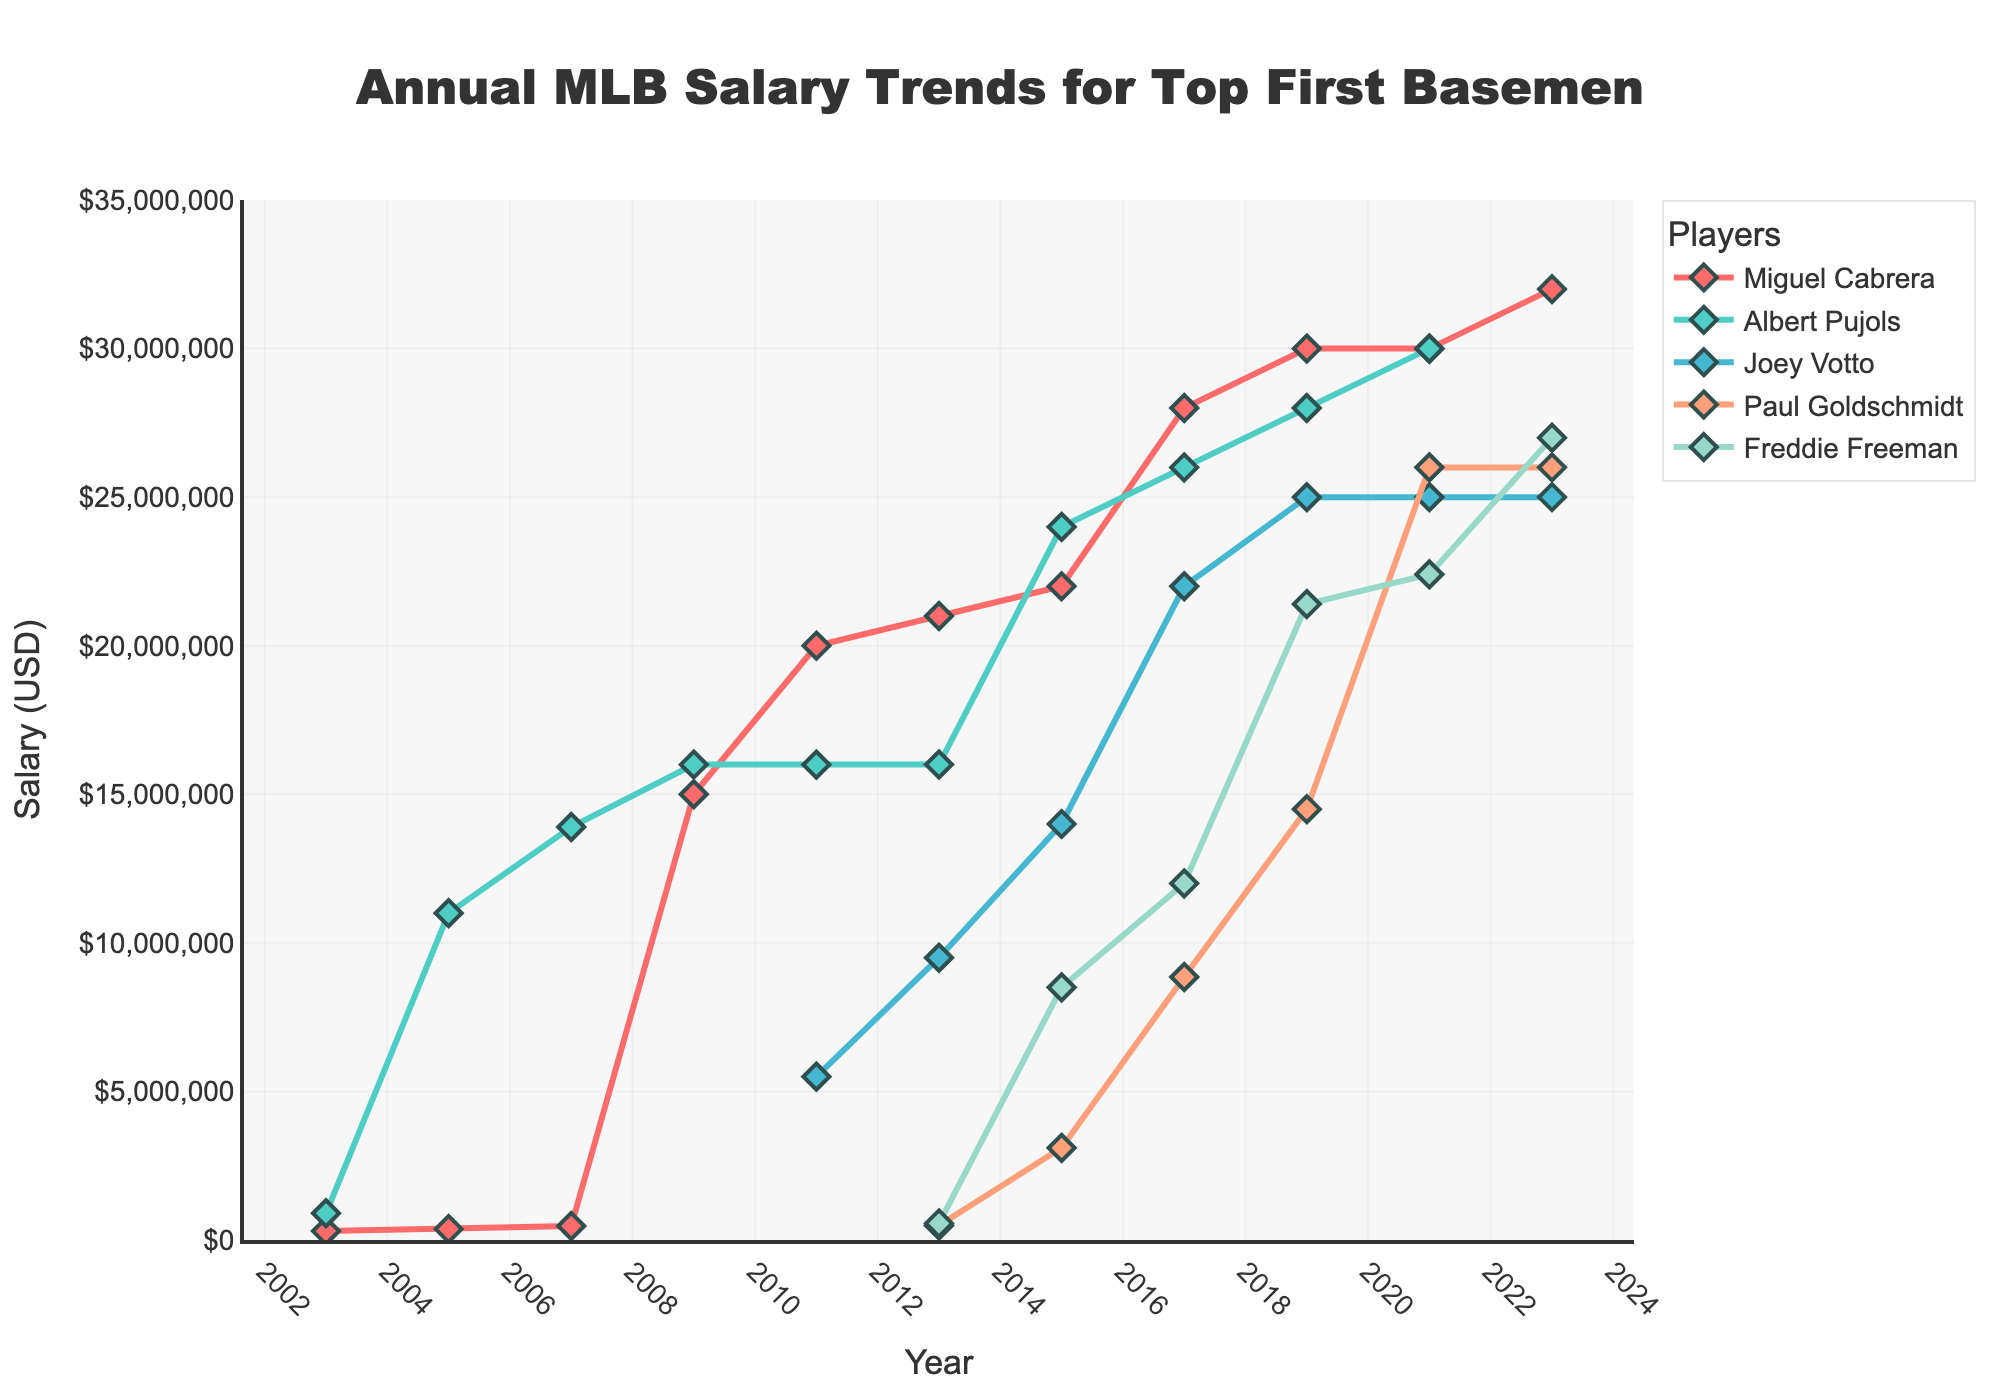What was the highest salary for Miguel Cabrera and in which year did it occur? Look at the trend line for Miguel Cabrera to find the peak salary. The highest salary is 32 million USD, which occurs in 2023.
Answer: 32 million USD, 2023 Who had the highest salary among all players in 2009? In 2009, Miguel Cabrera and Albert Pujols both have salaries. Compare their salary values, and Miguel Cabrera's salary of 15 million USD is lower than Pujols' 16 million USD, so Pujols is the highest paid.
Answer: Albert Pujols In what year did Freddie Freeman's salary first exceed Miguel Cabrera’s salary in the same year? Compare the salary lines for Miguel Cabrera and Freddie Freeman year by year. Freddie Freeman's salary first exceeds Miguel Cabrera's in 2023, with respective salaries of 27 million USD and 32 million USD.
Answer: Never in the given data Among the top first basemen, whose salary showed the most considerable increase between 2017 and 2019? Calculate the salary differences for each player between 2017 and 2019. Miguel Cabrera increased from 28 million USD to 30 million USD (+2 million). Albert Pujols increased from 26 million USD to 28 million USD (+2 million). Joey Votto increased from 22 million USD to 25 million USD (+3 million). Paul Goldschmidt increased from 8.85 million USD to 14.5 million USD (+5.65 million). Freddie Freeman increased from 12 million USD to 21.4 million USD (+9.4 million). Hence, Freddie Freeman had the most considerable increase of 9.4 million USD.
Answer: Freddie Freeman By how much did Joey Votto's salary grow from 2011 to 2019? Subtract Joey Votto's salary in 2011 (5.5 million USD) from his salary in 2019 (25 million USD): 25 million - 5.5 million = 19.5 million USD.
Answer: 19.5 million USD Which player's salary remained constant from 2021 to 2023? Examine the salary lines for all players between 2021 and 2023. Joey Votto's salary remains constant at 25 million USD while other players show changes.
Answer: Joey Votto In 2019, how much more did Miguel Cabrera make compared to Paul Goldschmidt? Subtract Paul Goldschmidt's salary in 2019 (14.5 million USD) from Miguel Cabrera's salary in 2019 (30 million USD): 30 million - 14.5 million = 15.5 million USD.
Answer: 15.5 million USD What is the average salary of Albert Pujols over the available years in the dataset? Sum the salaries of Albert Pujols for the years provided (9M + 11M + 13.9M + 16M + 16M + 16M + 24M + 26M + 28M + 30M) and divide by the number of years: (9 + 11 + 13.9 + 16 + 16 + 16 + 24 + 26 + 28 + 30) million USD / 10 years = 189.9 million / 10 = 18.99 million USD.
Answer: 18.99 million USD Which player had the lowest salary in 2015, and what was it? Compare the salaries for all players in 2015. Paul Goldschmidt had the lowest salary at 3.1 million USD.
Answer: Paul Goldschmidt, 3.1 million USD 